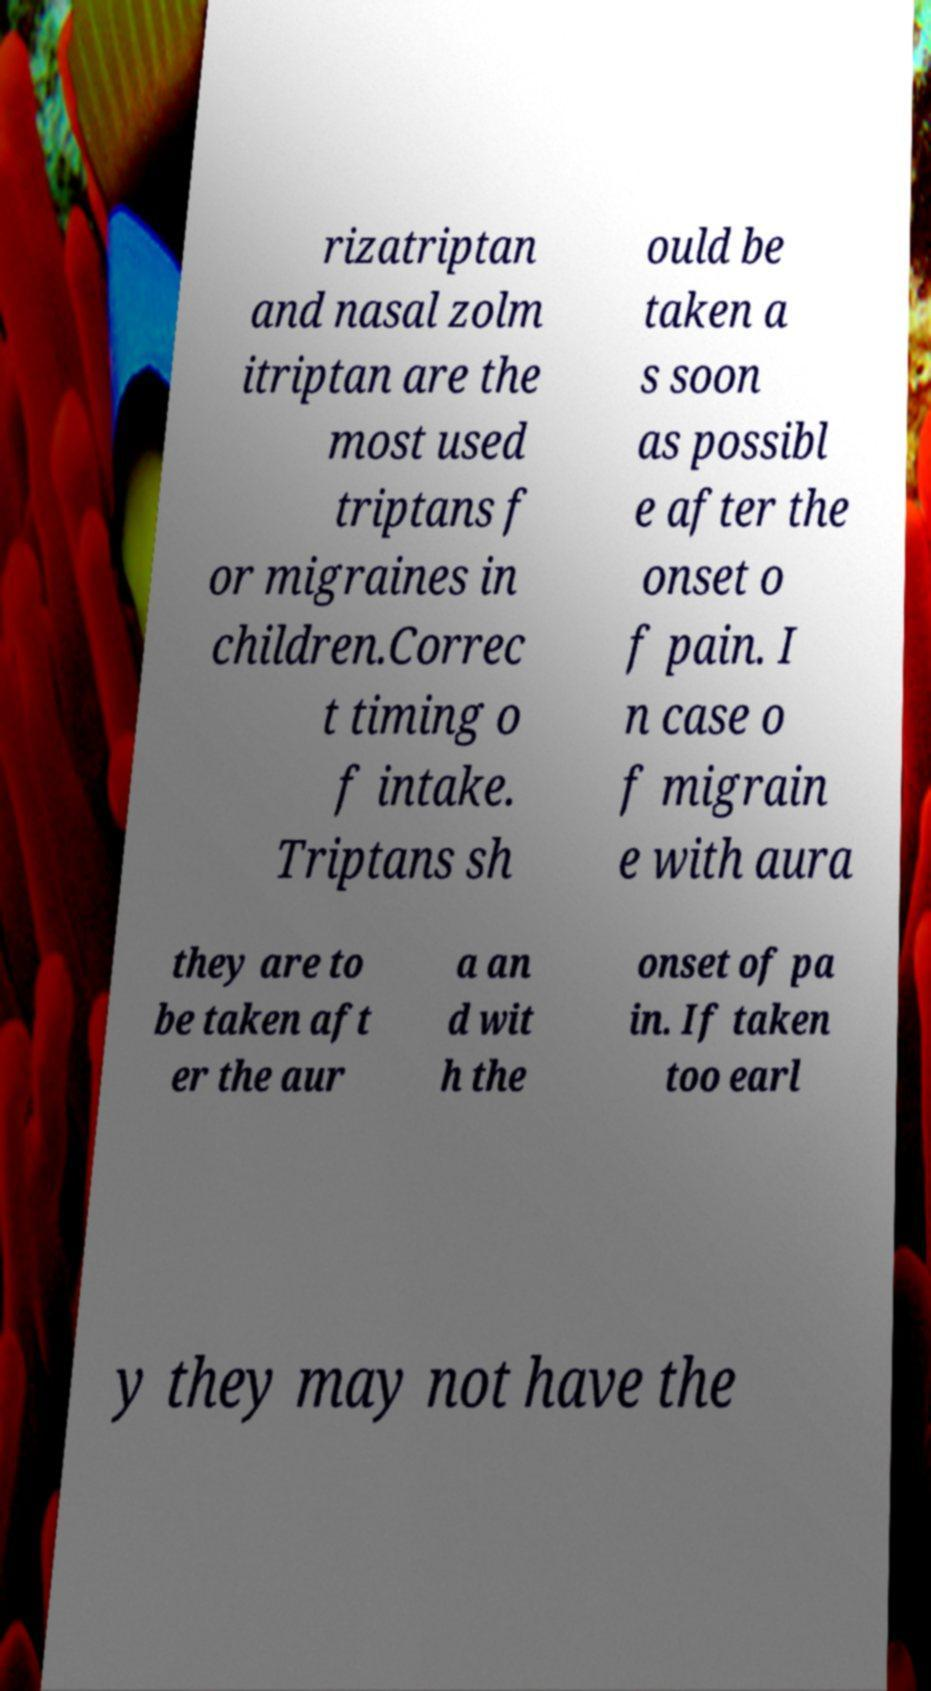Could you assist in decoding the text presented in this image and type it out clearly? rizatriptan and nasal zolm itriptan are the most used triptans f or migraines in children.Correc t timing o f intake. Triptans sh ould be taken a s soon as possibl e after the onset o f pain. I n case o f migrain e with aura they are to be taken aft er the aur a an d wit h the onset of pa in. If taken too earl y they may not have the 